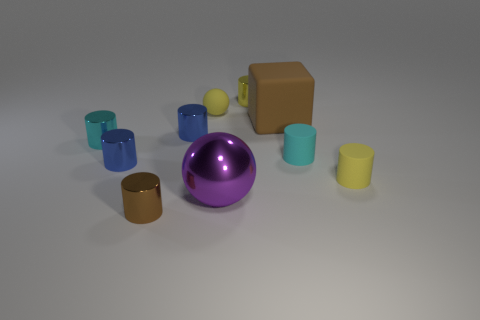There is a tiny cylinder that is both on the right side of the big purple thing and on the left side of the large block; what color is it?
Make the answer very short. Yellow. There is a small metallic object behind the yellow matte sphere; what number of cyan shiny things are to the right of it?
Offer a terse response. 0. Is there another metal object that has the same shape as the cyan metal object?
Offer a terse response. Yes. Does the blue object left of the tiny brown shiny object have the same shape as the cyan object on the right side of the purple object?
Your answer should be very brief. Yes. What number of objects are either yellow shiny things or metal objects?
Provide a short and direct response. 6. Is the number of small cyan metallic objects that are behind the brown cube greater than the number of blue cylinders?
Make the answer very short. No. Does the large ball have the same material as the tiny brown object?
Provide a succinct answer. Yes. What number of objects are tiny cylinders behind the small cyan metallic cylinder or cylinders right of the yellow metal cylinder?
Make the answer very short. 4. The other tiny rubber object that is the same shape as the small cyan matte object is what color?
Make the answer very short. Yellow. How many tiny objects are the same color as the large block?
Keep it short and to the point. 1. 